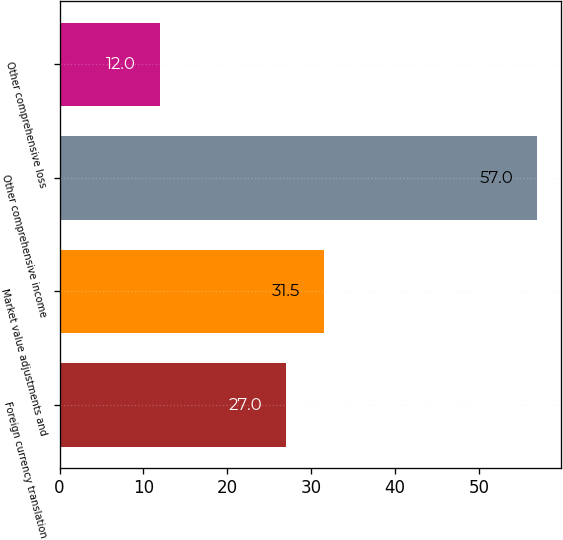Convert chart to OTSL. <chart><loc_0><loc_0><loc_500><loc_500><bar_chart><fcel>Foreign currency translation<fcel>Market value adjustments and<fcel>Other comprehensive income<fcel>Other comprehensive loss<nl><fcel>27<fcel>31.5<fcel>57<fcel>12<nl></chart> 